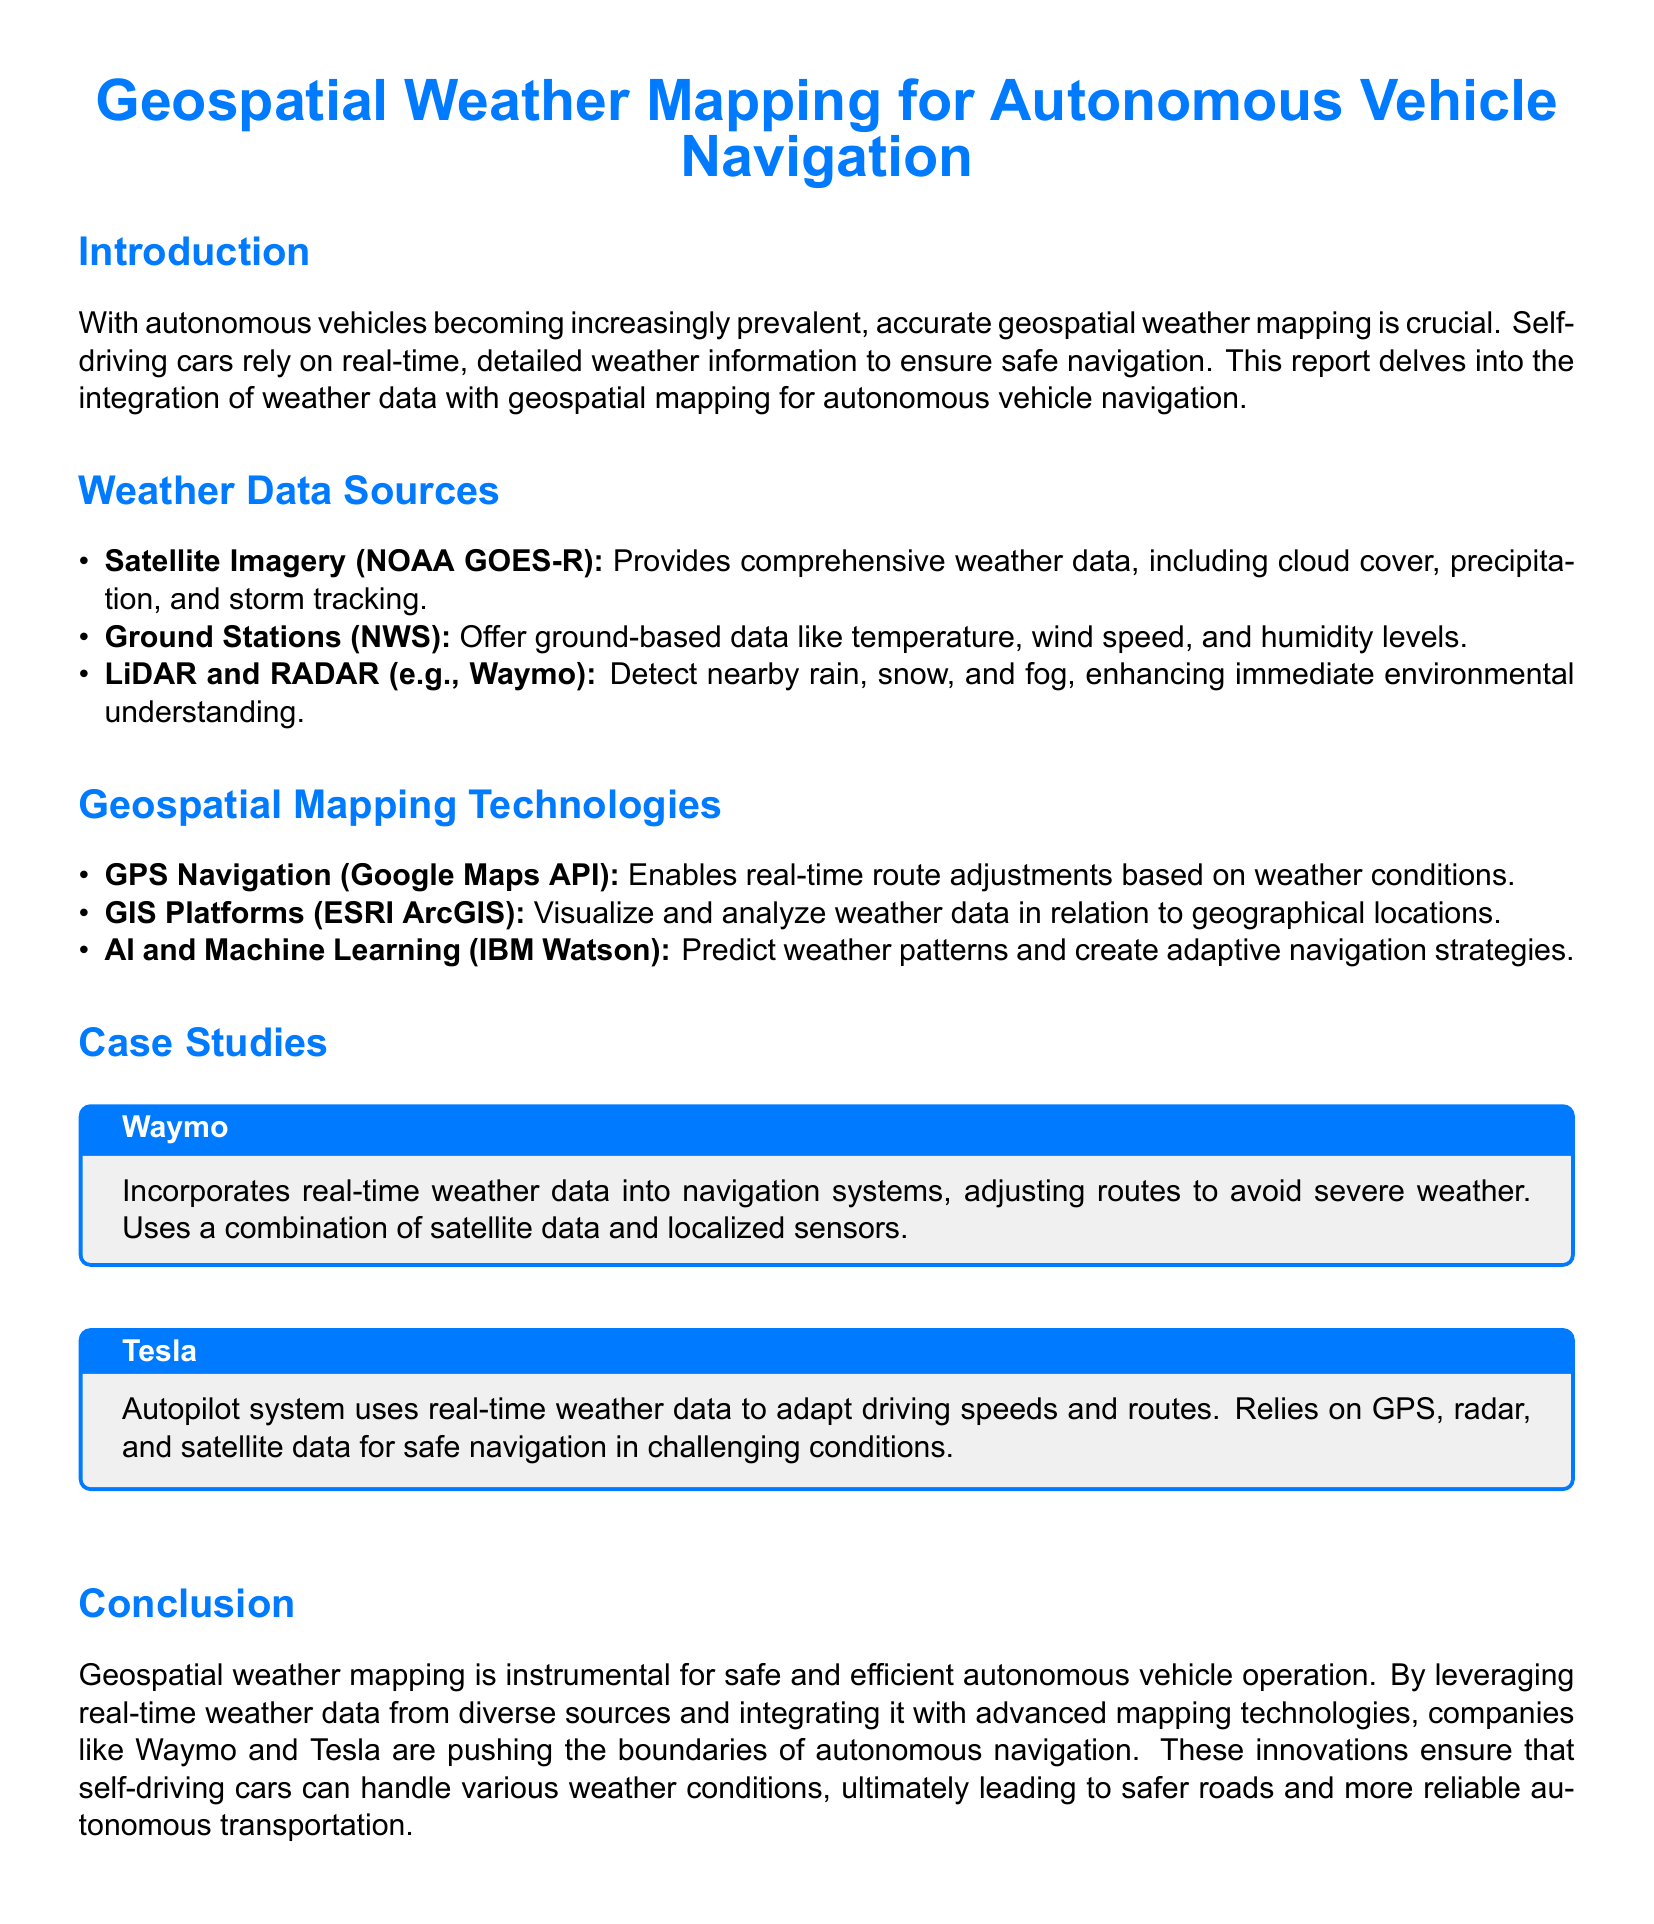What are the primary sources of weather data? The document lists three main sources of weather data: Satellite Imagery, Ground Stations, and LiDAR and RADAR.
Answer: Satellite Imagery, Ground Stations, LiDAR and RADAR Which technology enables real-time route adjustments based on weather conditions? The document specifies that GPS Navigation is used for real-time route adjustments based on weather.
Answer: GPS Navigation What is one application of AI and Machine Learning in weather mapping? The report mentions that AI and Machine Learning are used to predict weather patterns and create adaptive navigation strategies.
Answer: Predict weather patterns What company uses a combination of satellite data and localized sensors for navigation? The document states that Waymo incorporates real-time weather data into navigation systems using satellite data and localized sensors.
Answer: Waymo How does Tesla's Autopilot system adapt to weather conditions? The report indicates that Tesla's Autopilot system uses real-time weather data to adapt driving speeds and routes.
Answer: Adapt driving speeds and routes What weather data source provides cloud cover and precipitation information? The document notes that Satellite Imagery (specifically NOAA GOES-R) provides cloud cover and precipitation information.
Answer: Satellite Imagery What is the primary focus of the report? The document focuses on the importance of geospatial weather mapping for the safe navigation of autonomous vehicles.
Answer: Geospatial weather mapping What color is used for section titles in the document? The document defines the color "techblue" for section titles.
Answer: techblue 